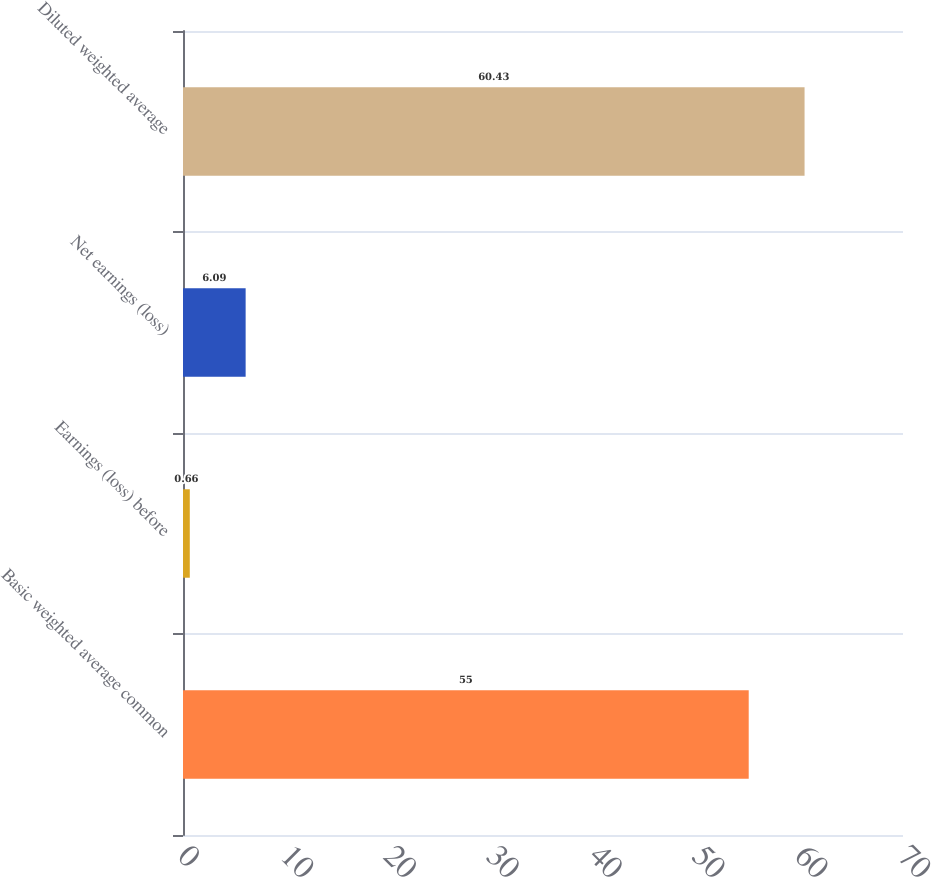Convert chart. <chart><loc_0><loc_0><loc_500><loc_500><bar_chart><fcel>Basic weighted average common<fcel>Earnings (loss) before<fcel>Net earnings (loss)<fcel>Diluted weighted average<nl><fcel>55<fcel>0.66<fcel>6.09<fcel>60.43<nl></chart> 